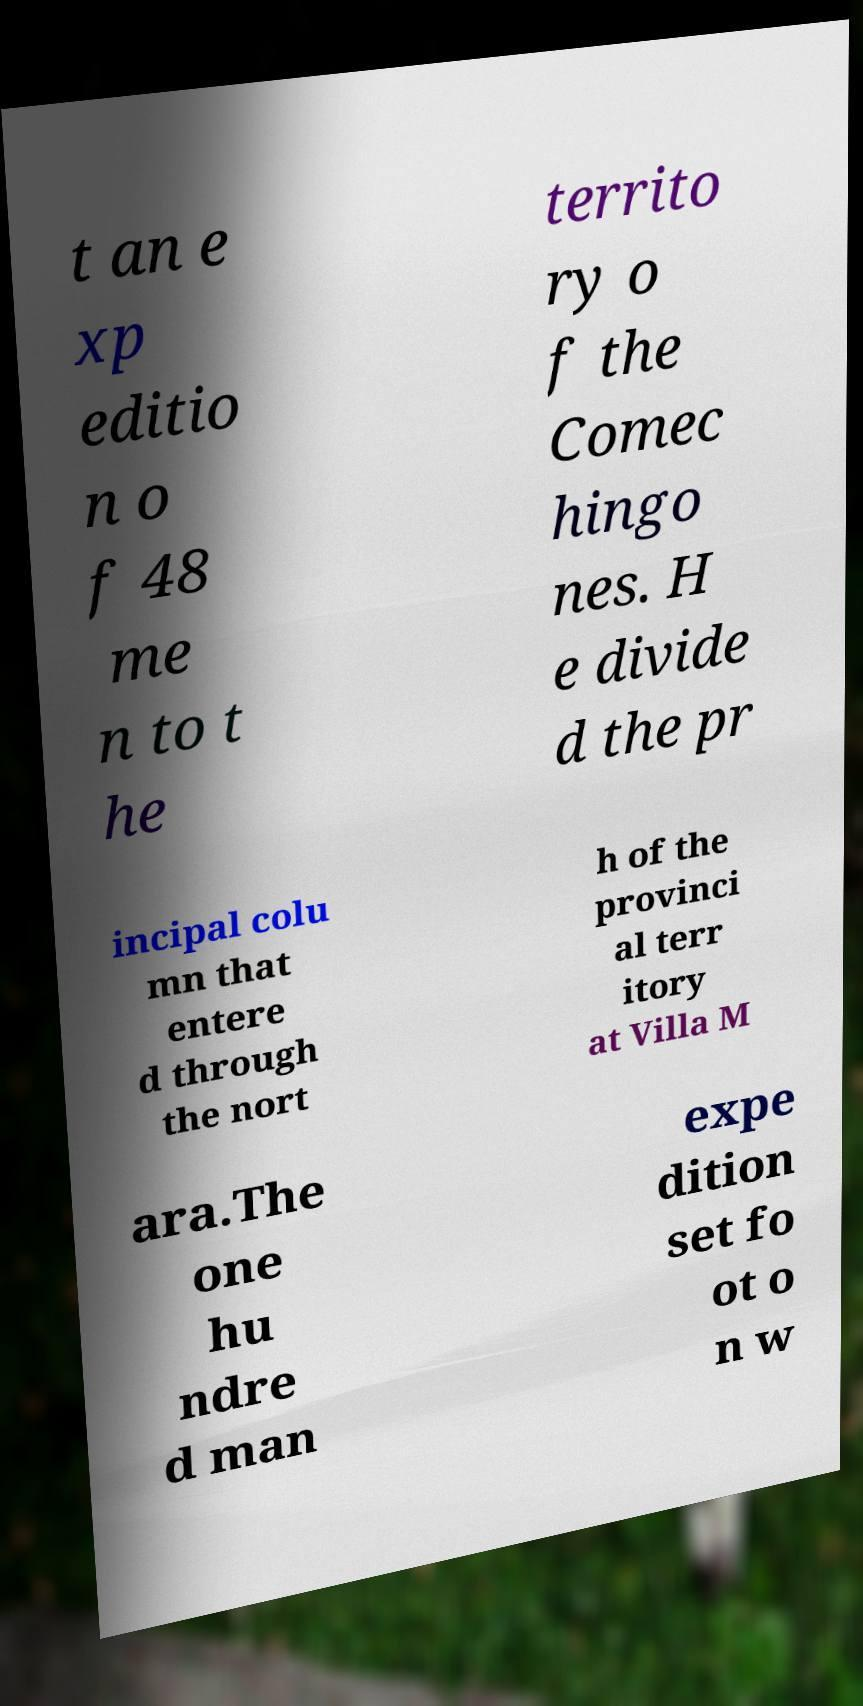There's text embedded in this image that I need extracted. Can you transcribe it verbatim? t an e xp editio n o f 48 me n to t he territo ry o f the Comec hingo nes. H e divide d the pr incipal colu mn that entere d through the nort h of the provinci al terr itory at Villa M ara.The one hu ndre d man expe dition set fo ot o n w 